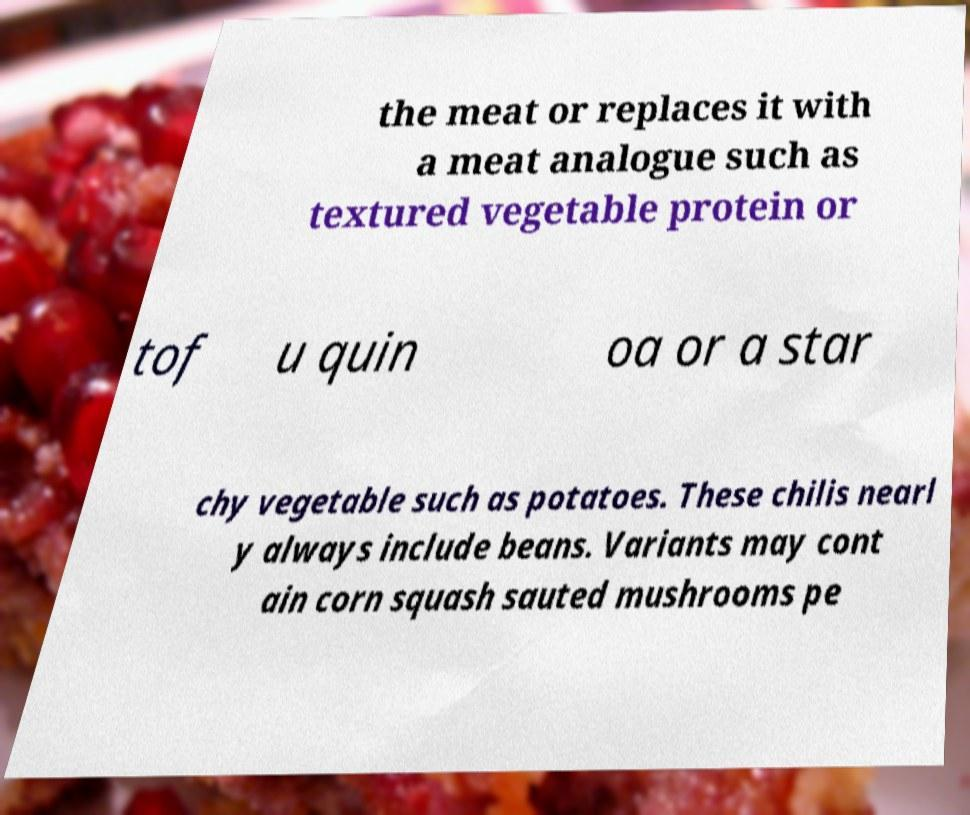For documentation purposes, I need the text within this image transcribed. Could you provide that? the meat or replaces it with a meat analogue such as textured vegetable protein or tof u quin oa or a star chy vegetable such as potatoes. These chilis nearl y always include beans. Variants may cont ain corn squash sauted mushrooms pe 